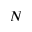<formula> <loc_0><loc_0><loc_500><loc_500>N</formula> 